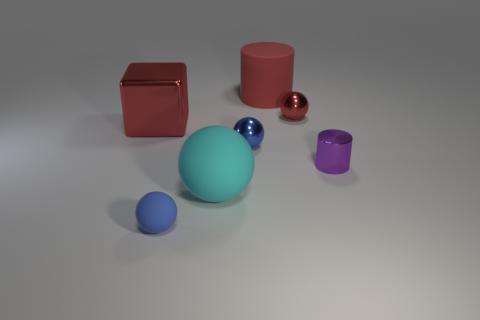What number of small metal spheres have the same color as the small matte object?
Keep it short and to the point. 1. How many big red cylinders are the same material as the block?
Your answer should be compact. 0. Is the shape of the large red thing that is left of the small blue metal sphere the same as the large matte thing that is in front of the purple shiny cylinder?
Your answer should be very brief. No. What is the color of the cylinder right of the tiny red thing?
Offer a very short reply. Purple. Are there any red metallic objects of the same shape as the tiny rubber thing?
Your answer should be very brief. Yes. What is the material of the purple cylinder?
Provide a succinct answer. Metal. What size is the metallic thing that is to the right of the red shiny cube and to the left of the large matte cylinder?
Provide a succinct answer. Small. There is a large object that is the same color as the metallic cube; what is its material?
Offer a terse response. Rubber. How many tiny blue metal balls are there?
Keep it short and to the point. 1. Are there fewer big red objects than small blue cubes?
Keep it short and to the point. No. 